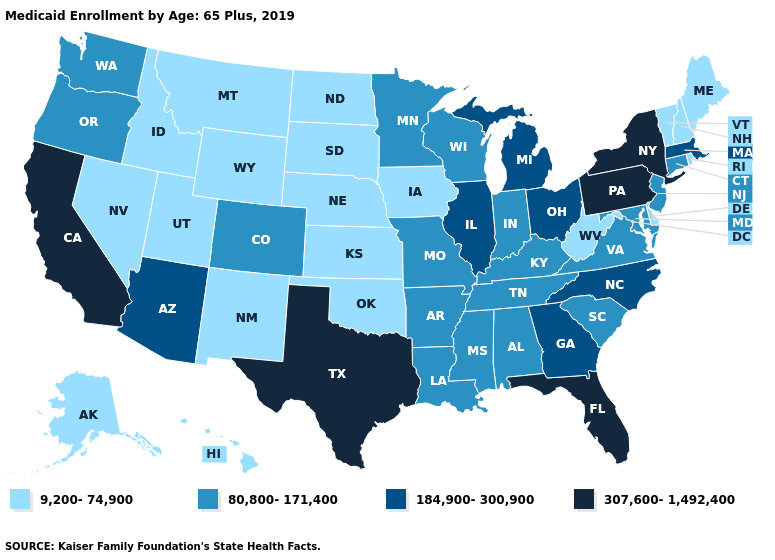Name the states that have a value in the range 307,600-1,492,400?
Answer briefly. California, Florida, New York, Pennsylvania, Texas. What is the highest value in the USA?
Write a very short answer. 307,600-1,492,400. Does North Carolina have a lower value than New Jersey?
Quick response, please. No. What is the value of Kentucky?
Write a very short answer. 80,800-171,400. What is the value of California?
Be succinct. 307,600-1,492,400. What is the lowest value in the West?
Be succinct. 9,200-74,900. Name the states that have a value in the range 80,800-171,400?
Quick response, please. Alabama, Arkansas, Colorado, Connecticut, Indiana, Kentucky, Louisiana, Maryland, Minnesota, Mississippi, Missouri, New Jersey, Oregon, South Carolina, Tennessee, Virginia, Washington, Wisconsin. Does Alaska have the lowest value in the West?
Write a very short answer. Yes. Among the states that border Arizona , which have the highest value?
Be succinct. California. What is the value of Utah?
Short answer required. 9,200-74,900. Which states hav the highest value in the South?
Concise answer only. Florida, Texas. Which states hav the highest value in the MidWest?
Keep it brief. Illinois, Michigan, Ohio. Does Montana have the same value as Maine?
Short answer required. Yes. Name the states that have a value in the range 9,200-74,900?
Give a very brief answer. Alaska, Delaware, Hawaii, Idaho, Iowa, Kansas, Maine, Montana, Nebraska, Nevada, New Hampshire, New Mexico, North Dakota, Oklahoma, Rhode Island, South Dakota, Utah, Vermont, West Virginia, Wyoming. What is the value of Wisconsin?
Give a very brief answer. 80,800-171,400. 